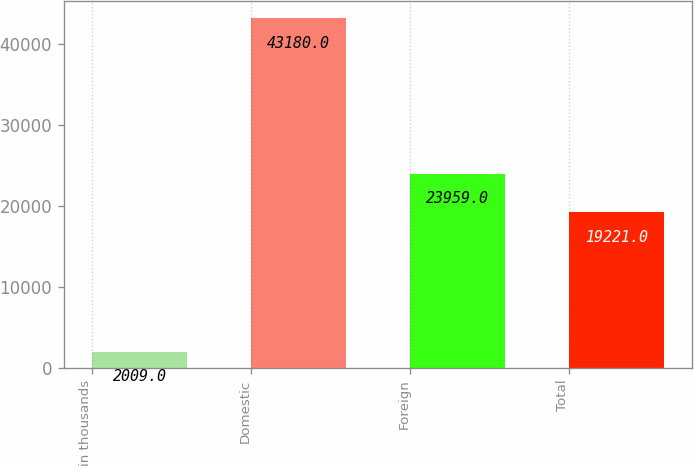Convert chart. <chart><loc_0><loc_0><loc_500><loc_500><bar_chart><fcel>in thousands<fcel>Domestic<fcel>Foreign<fcel>Total<nl><fcel>2009<fcel>43180<fcel>23959<fcel>19221<nl></chart> 